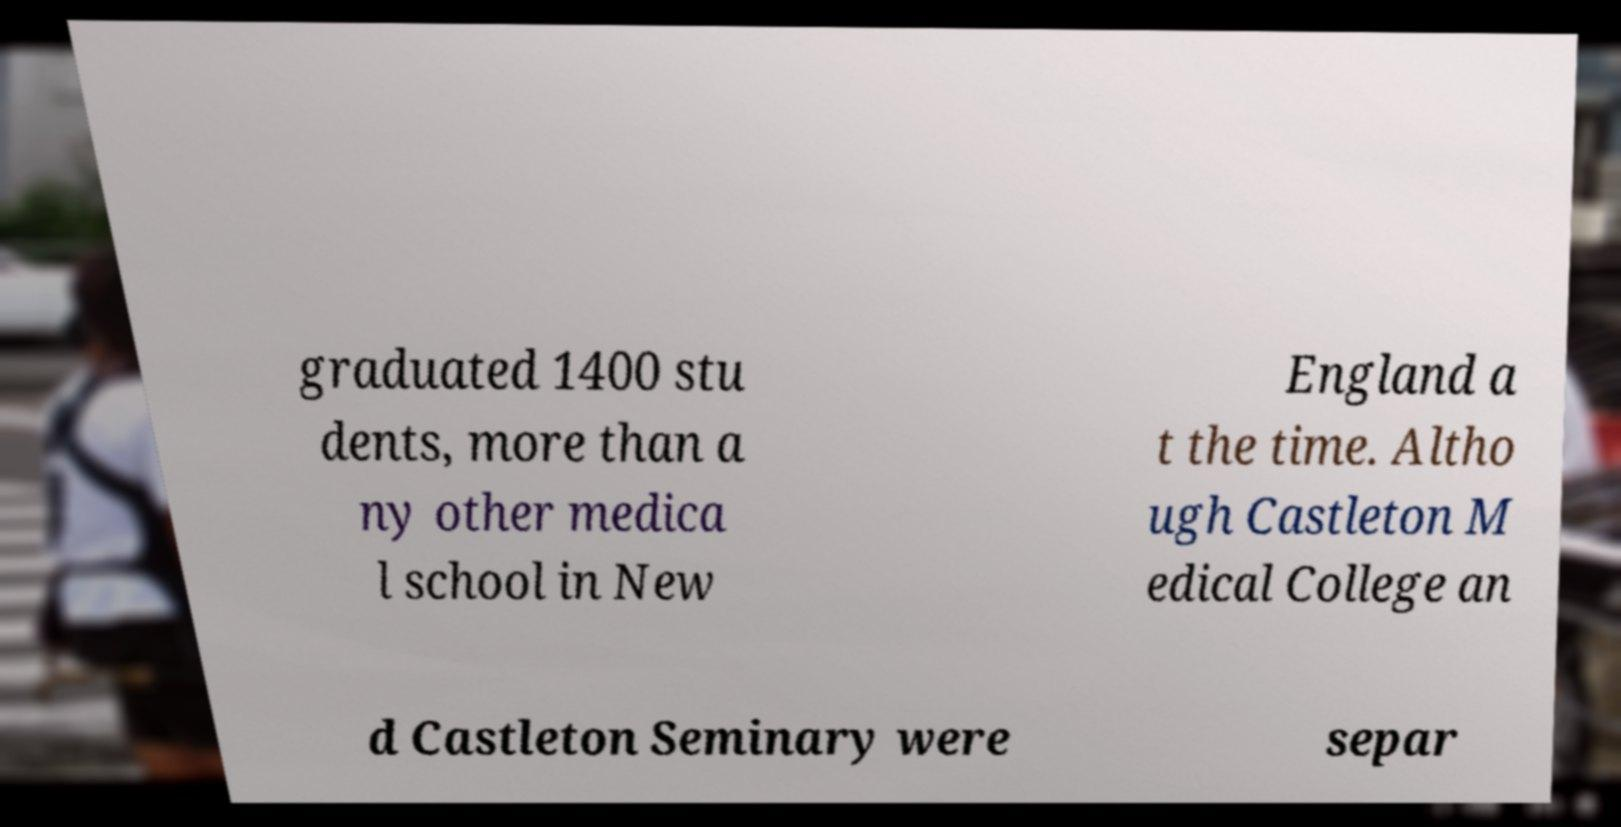Could you extract and type out the text from this image? graduated 1400 stu dents, more than a ny other medica l school in New England a t the time. Altho ugh Castleton M edical College an d Castleton Seminary were separ 